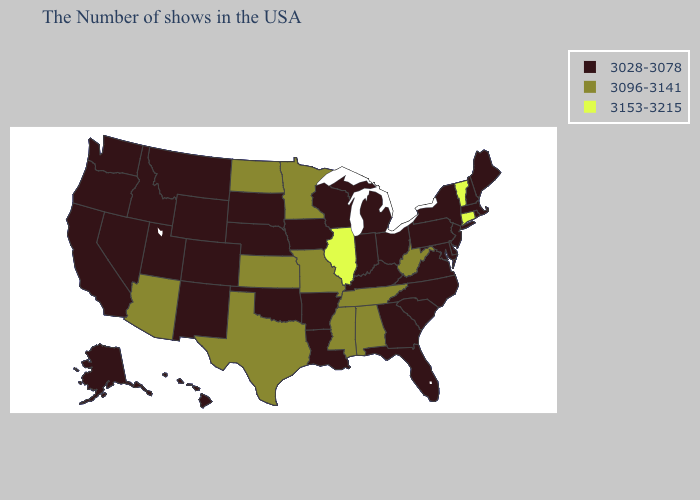Among the states that border Pennsylvania , which have the highest value?
Keep it brief. West Virginia. Does North Dakota have the lowest value in the MidWest?
Write a very short answer. No. Name the states that have a value in the range 3028-3078?
Short answer required. Maine, Massachusetts, Rhode Island, New Hampshire, New York, New Jersey, Delaware, Maryland, Pennsylvania, Virginia, North Carolina, South Carolina, Ohio, Florida, Georgia, Michigan, Kentucky, Indiana, Wisconsin, Louisiana, Arkansas, Iowa, Nebraska, Oklahoma, South Dakota, Wyoming, Colorado, New Mexico, Utah, Montana, Idaho, Nevada, California, Washington, Oregon, Alaska, Hawaii. Name the states that have a value in the range 3028-3078?
Give a very brief answer. Maine, Massachusetts, Rhode Island, New Hampshire, New York, New Jersey, Delaware, Maryland, Pennsylvania, Virginia, North Carolina, South Carolina, Ohio, Florida, Georgia, Michigan, Kentucky, Indiana, Wisconsin, Louisiana, Arkansas, Iowa, Nebraska, Oklahoma, South Dakota, Wyoming, Colorado, New Mexico, Utah, Montana, Idaho, Nevada, California, Washington, Oregon, Alaska, Hawaii. Among the states that border Utah , which have the highest value?
Answer briefly. Arizona. Among the states that border Montana , which have the lowest value?
Write a very short answer. South Dakota, Wyoming, Idaho. What is the highest value in states that border Missouri?
Give a very brief answer. 3153-3215. Name the states that have a value in the range 3153-3215?
Answer briefly. Vermont, Connecticut, Illinois. Does West Virginia have the lowest value in the South?
Answer briefly. No. Does the first symbol in the legend represent the smallest category?
Quick response, please. Yes. What is the lowest value in states that border Idaho?
Concise answer only. 3028-3078. Does Montana have a lower value than New Mexico?
Be succinct. No. What is the lowest value in the Northeast?
Quick response, please. 3028-3078. Name the states that have a value in the range 3096-3141?
Concise answer only. West Virginia, Alabama, Tennessee, Mississippi, Missouri, Minnesota, Kansas, Texas, North Dakota, Arizona. Name the states that have a value in the range 3153-3215?
Be succinct. Vermont, Connecticut, Illinois. 